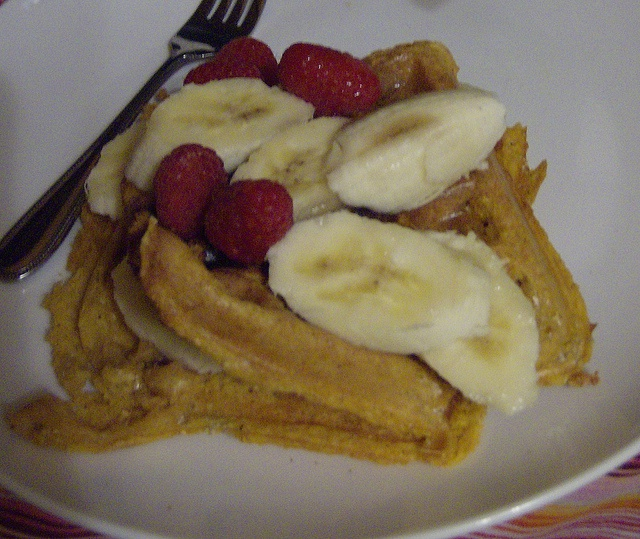Describe the objects in this image and their specific colors. I can see banana in purple, tan, and gray tones and fork in purple, black, gray, navy, and darkgreen tones in this image. 